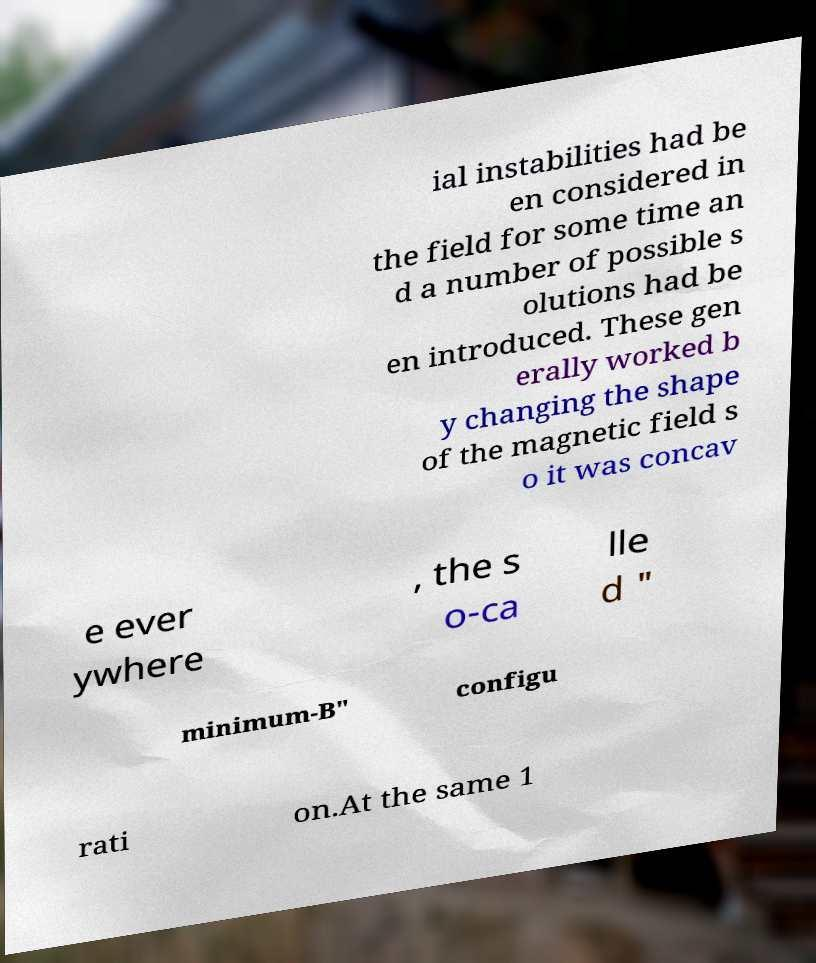What messages or text are displayed in this image? I need them in a readable, typed format. ial instabilities had be en considered in the field for some time an d a number of possible s olutions had be en introduced. These gen erally worked b y changing the shape of the magnetic field s o it was concav e ever ywhere , the s o-ca lle d " minimum-B" configu rati on.At the same 1 